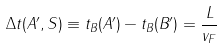Convert formula to latex. <formula><loc_0><loc_0><loc_500><loc_500>\Delta t ( A ^ { \prime } , S ) \equiv t _ { B } ( A ^ { \prime } ) - t _ { B } ( B ^ { \prime } ) = \frac { L } { v _ { F } }</formula> 